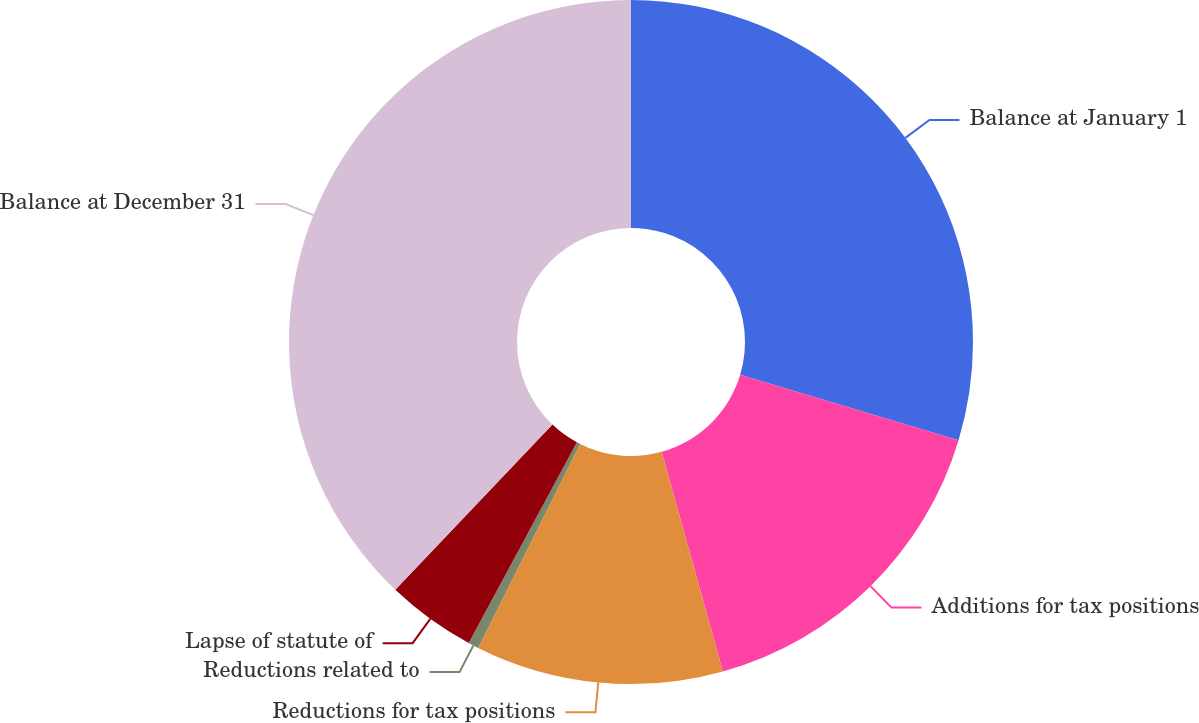<chart> <loc_0><loc_0><loc_500><loc_500><pie_chart><fcel>Balance at January 1<fcel>Additions for tax positions<fcel>Reductions for tax positions<fcel>Reductions related to<fcel>Lapse of statute of<fcel>Balance at December 31<nl><fcel>29.64%<fcel>16.03%<fcel>11.71%<fcel>0.49%<fcel>4.23%<fcel>37.9%<nl></chart> 